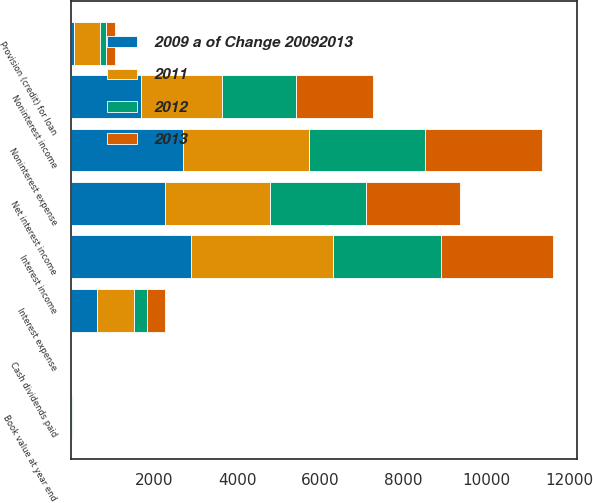Convert chart to OTSL. <chart><loc_0><loc_0><loc_500><loc_500><stacked_bar_chart><ecel><fcel>Interest income<fcel>Interest expense<fcel>Net interest income<fcel>Provision (credit) for loan<fcel>Noninterest income<fcel>Noninterest expense<fcel>Cash dividends paid<fcel>Book value at year end<nl><fcel>2012<fcel>2620<fcel>295<fcel>2325<fcel>130<fcel>1766<fcel>2820<fcel>0.21<fcel>11.25<nl><fcel>2013<fcel>2705<fcel>441<fcel>2264<fcel>229<fcel>1856<fcel>2818<fcel>0.18<fcel>10.78<nl><fcel>2009 a of Change 20092013<fcel>2889<fcel>622<fcel>2267<fcel>60<fcel>1688<fcel>2684<fcel>0.1<fcel>10.09<nl><fcel>2011<fcel>3408<fcel>897<fcel>2511<fcel>638<fcel>1954<fcel>3034<fcel>0.04<fcel>9.52<nl></chart> 